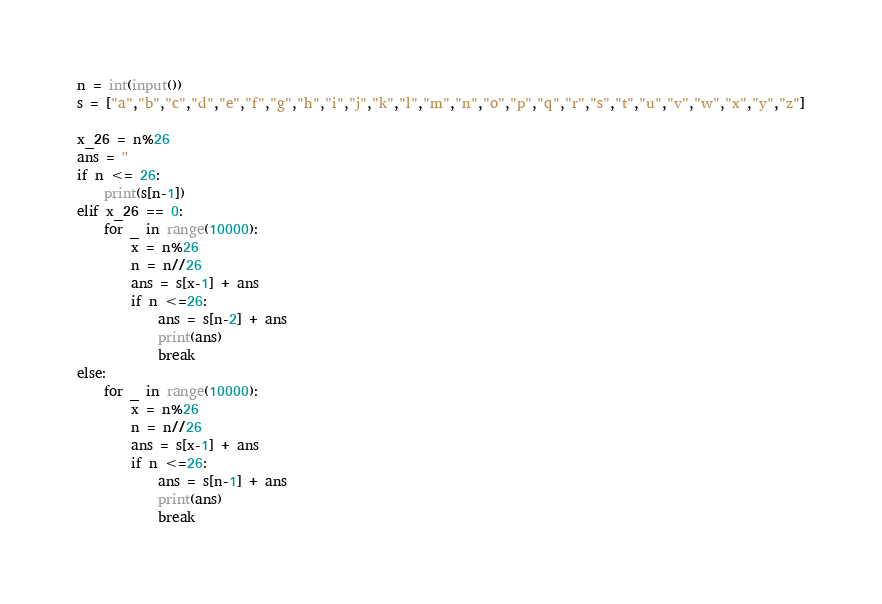<code> <loc_0><loc_0><loc_500><loc_500><_Python_>n = int(input())
s = ["a","b","c","d","e","f","g","h","i","j","k","l","m","n","o","p","q","r","s","t","u","v","w","x","y","z"]

x_26 = n%26
ans = ''
if n <= 26:
    print(s[n-1])
elif x_26 == 0:
    for _ in range(10000):
        x = n%26
        n = n//26
        ans = s[x-1] + ans
        if n <=26:
            ans = s[n-2] + ans
            print(ans)
            break
else:
    for _ in range(10000):
        x = n%26
        n = n//26
        ans = s[x-1] + ans
        if n <=26:
            ans = s[n-1] + ans
            print(ans)
            break
</code> 